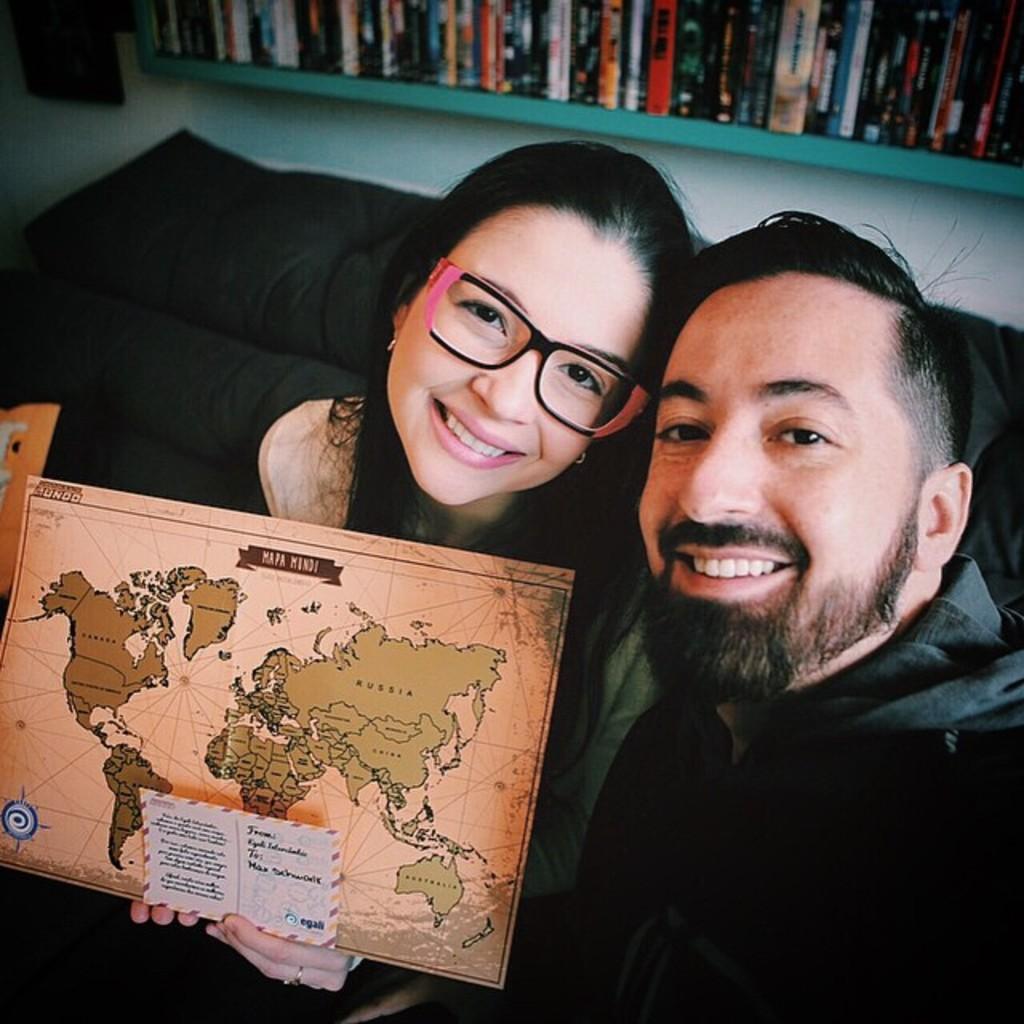Could you give a brief overview of what you see in this image? In this image a woman and a person are sitting on the sofa. The woman is wearing spectacles. She is holding papers. There is an image on a paper. There is some text on the other paper. Top of the image there is a shelf having books. 